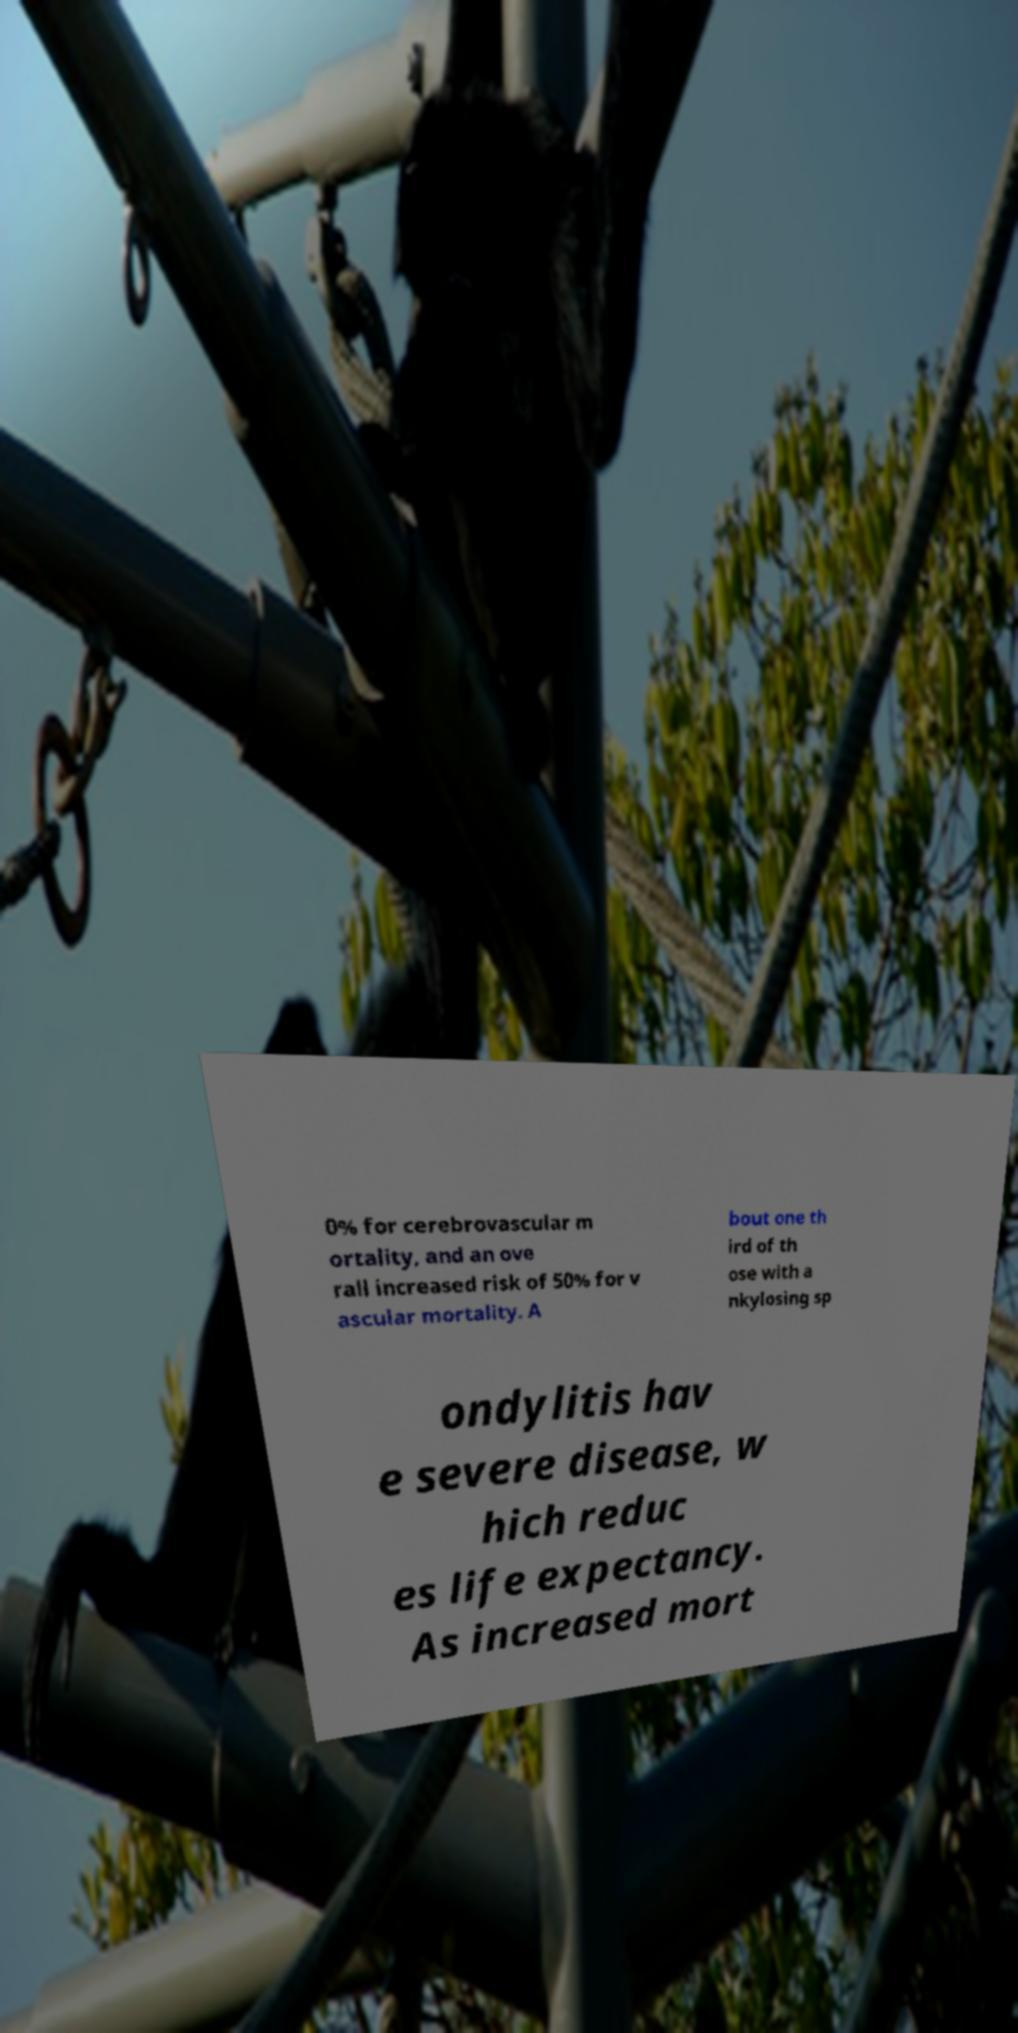There's text embedded in this image that I need extracted. Can you transcribe it verbatim? 0% for cerebrovascular m ortality, and an ove rall increased risk of 50% for v ascular mortality. A bout one th ird of th ose with a nkylosing sp ondylitis hav e severe disease, w hich reduc es life expectancy. As increased mort 